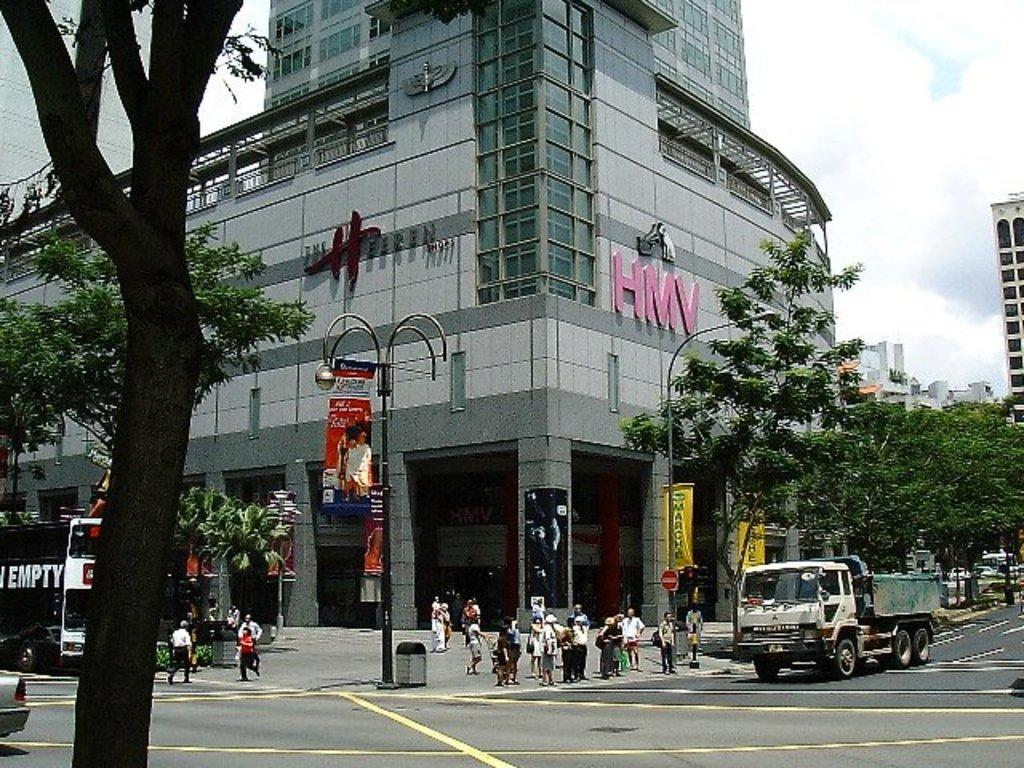What type of structures can be seen in the image? There are buildings in the image. What other natural elements are present in the image? There are trees in the image. What man-made objects can be seen in the image? There are poles, vehicles, and lights in the image. Are there any living beings in the image? Yes, there are people in the image. What type of signage is present in the image? There are posters with text and images in the image. What is visible in the background of the image? The sky is visible in the image, and there are clouds in the sky. Can you tell me how many goats are standing on the table in the image? There are no goats present in the image, and there is no table in the image. What color is the sky in the image? The sky is visible in the image, but the color is not mentioned in the provided facts. 